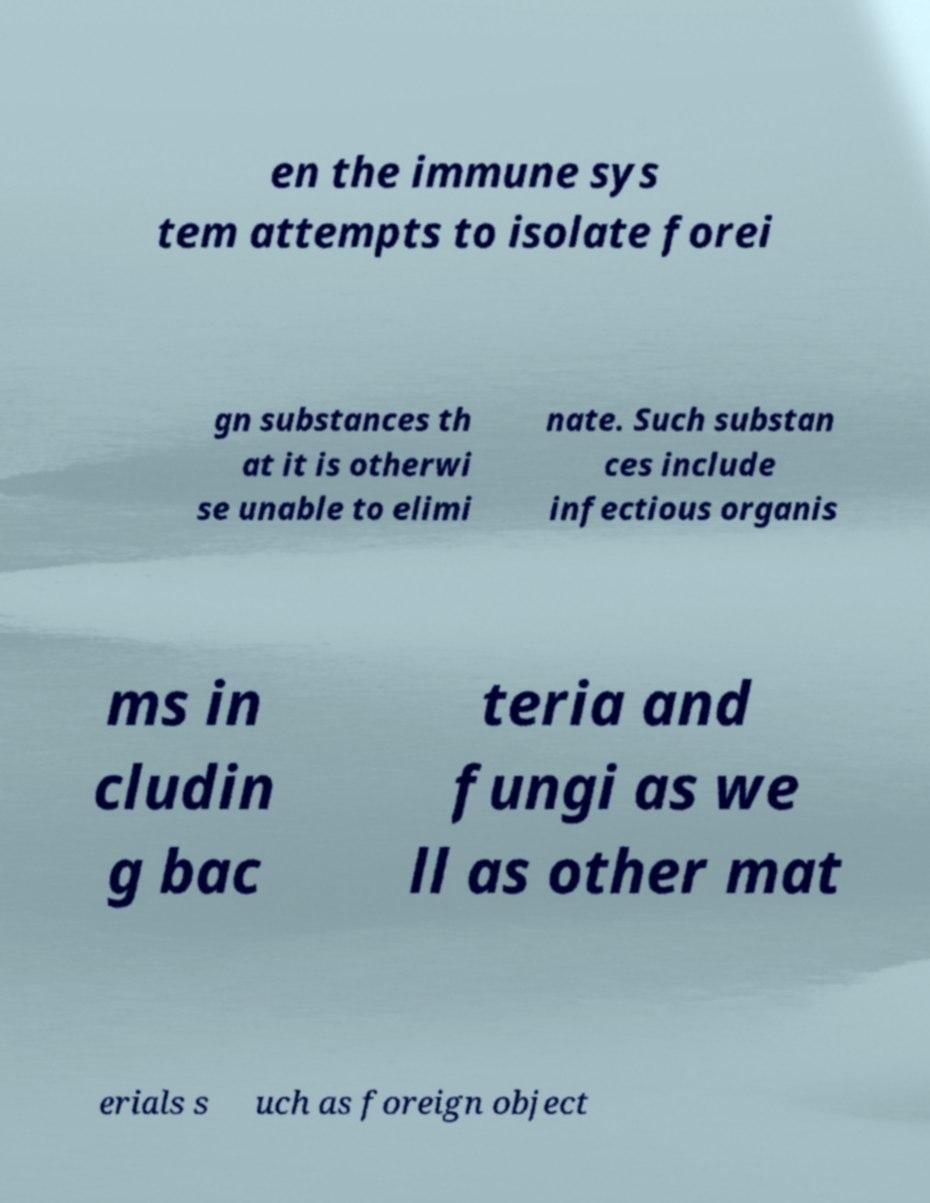Can you accurately transcribe the text from the provided image for me? en the immune sys tem attempts to isolate forei gn substances th at it is otherwi se unable to elimi nate. Such substan ces include infectious organis ms in cludin g bac teria and fungi as we ll as other mat erials s uch as foreign object 